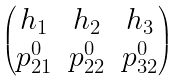<formula> <loc_0><loc_0><loc_500><loc_500>\begin{pmatrix} h _ { 1 } & h _ { 2 } & h _ { 3 } \\ p _ { 2 1 } ^ { 0 } & p _ { 2 2 } ^ { 0 } & p _ { 3 2 } ^ { 0 } \end{pmatrix}</formula> 